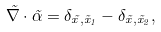<formula> <loc_0><loc_0><loc_500><loc_500>\vec { \nabla } \cdot \vec { \alpha } = \delta _ { \vec { x } , \vec { x } _ { 1 } } - \delta _ { \vec { x } , \vec { x } _ { 2 } } ,</formula> 